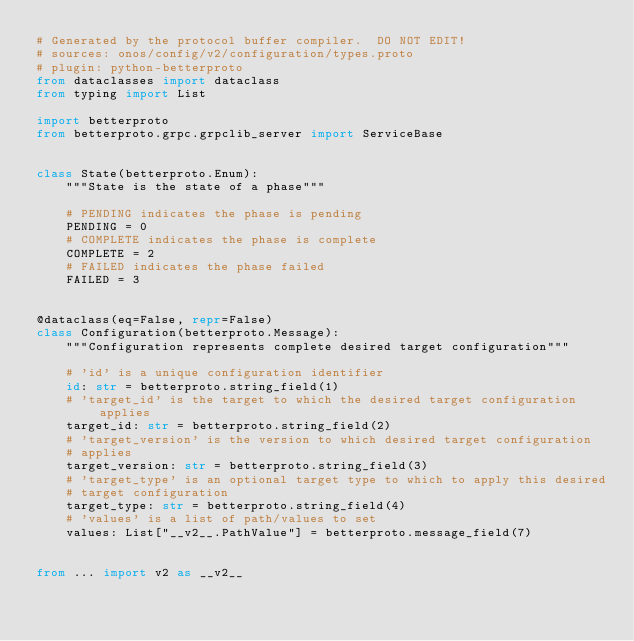Convert code to text. <code><loc_0><loc_0><loc_500><loc_500><_Python_># Generated by the protocol buffer compiler.  DO NOT EDIT!
# sources: onos/config/v2/configuration/types.proto
# plugin: python-betterproto
from dataclasses import dataclass
from typing import List

import betterproto
from betterproto.grpc.grpclib_server import ServiceBase


class State(betterproto.Enum):
    """State is the state of a phase"""

    # PENDING indicates the phase is pending
    PENDING = 0
    # COMPLETE indicates the phase is complete
    COMPLETE = 2
    # FAILED indicates the phase failed
    FAILED = 3


@dataclass(eq=False, repr=False)
class Configuration(betterproto.Message):
    """Configuration represents complete desired target configuration"""

    # 'id' is a unique configuration identifier
    id: str = betterproto.string_field(1)
    # 'target_id' is the target to which the desired target configuration applies
    target_id: str = betterproto.string_field(2)
    # 'target_version' is the version to which desired target configuration
    # applies
    target_version: str = betterproto.string_field(3)
    # 'target_type' is an optional target type to which to apply this desired
    # target configuration
    target_type: str = betterproto.string_field(4)
    # 'values' is a list of path/values to set
    values: List["__v2__.PathValue"] = betterproto.message_field(7)


from ... import v2 as __v2__
</code> 